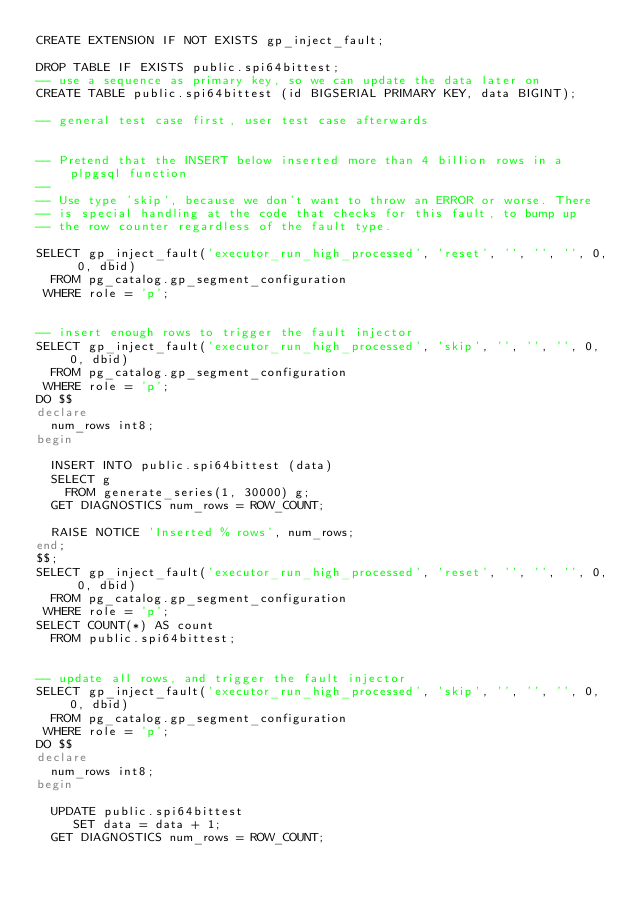Convert code to text. <code><loc_0><loc_0><loc_500><loc_500><_SQL_>CREATE EXTENSION IF NOT EXISTS gp_inject_fault;

DROP TABLE IF EXISTS public.spi64bittest;
-- use a sequence as primary key, so we can update the data later on
CREATE TABLE public.spi64bittest (id BIGSERIAL PRIMARY KEY, data BIGINT);

-- general test case first, user test case afterwards


-- Pretend that the INSERT below inserted more than 4 billion rows in a plpgsql function
--
-- Use type 'skip', because we don't want to throw an ERROR or worse. There
-- is special handling at the code that checks for this fault, to bump up
-- the row counter regardless of the fault type.

SELECT gp_inject_fault('executor_run_high_processed', 'reset', '', '', '', 0, 0, dbid)
  FROM pg_catalog.gp_segment_configuration
 WHERE role = 'p';


-- insert enough rows to trigger the fault injector
SELECT gp_inject_fault('executor_run_high_processed', 'skip', '', '', '', 0, 0, dbid)
  FROM pg_catalog.gp_segment_configuration
 WHERE role = 'p';
DO $$
declare
  num_rows int8;
begin

  INSERT INTO public.spi64bittest (data)
  SELECT g
    FROM generate_series(1, 30000) g;
  GET DIAGNOSTICS num_rows = ROW_COUNT;

  RAISE NOTICE 'Inserted % rows', num_rows;
end;
$$;
SELECT gp_inject_fault('executor_run_high_processed', 'reset', '', '', '', 0, 0, dbid)
  FROM pg_catalog.gp_segment_configuration
 WHERE role = 'p';
SELECT COUNT(*) AS count
  FROM public.spi64bittest;


-- update all rows, and trigger the fault injector
SELECT gp_inject_fault('executor_run_high_processed', 'skip', '', '', '', 0, 0, dbid)
  FROM pg_catalog.gp_segment_configuration
 WHERE role = 'p';
DO $$
declare
  num_rows int8;
begin

  UPDATE public.spi64bittest
     SET data = data + 1;
  GET DIAGNOSTICS num_rows = ROW_COUNT;
</code> 